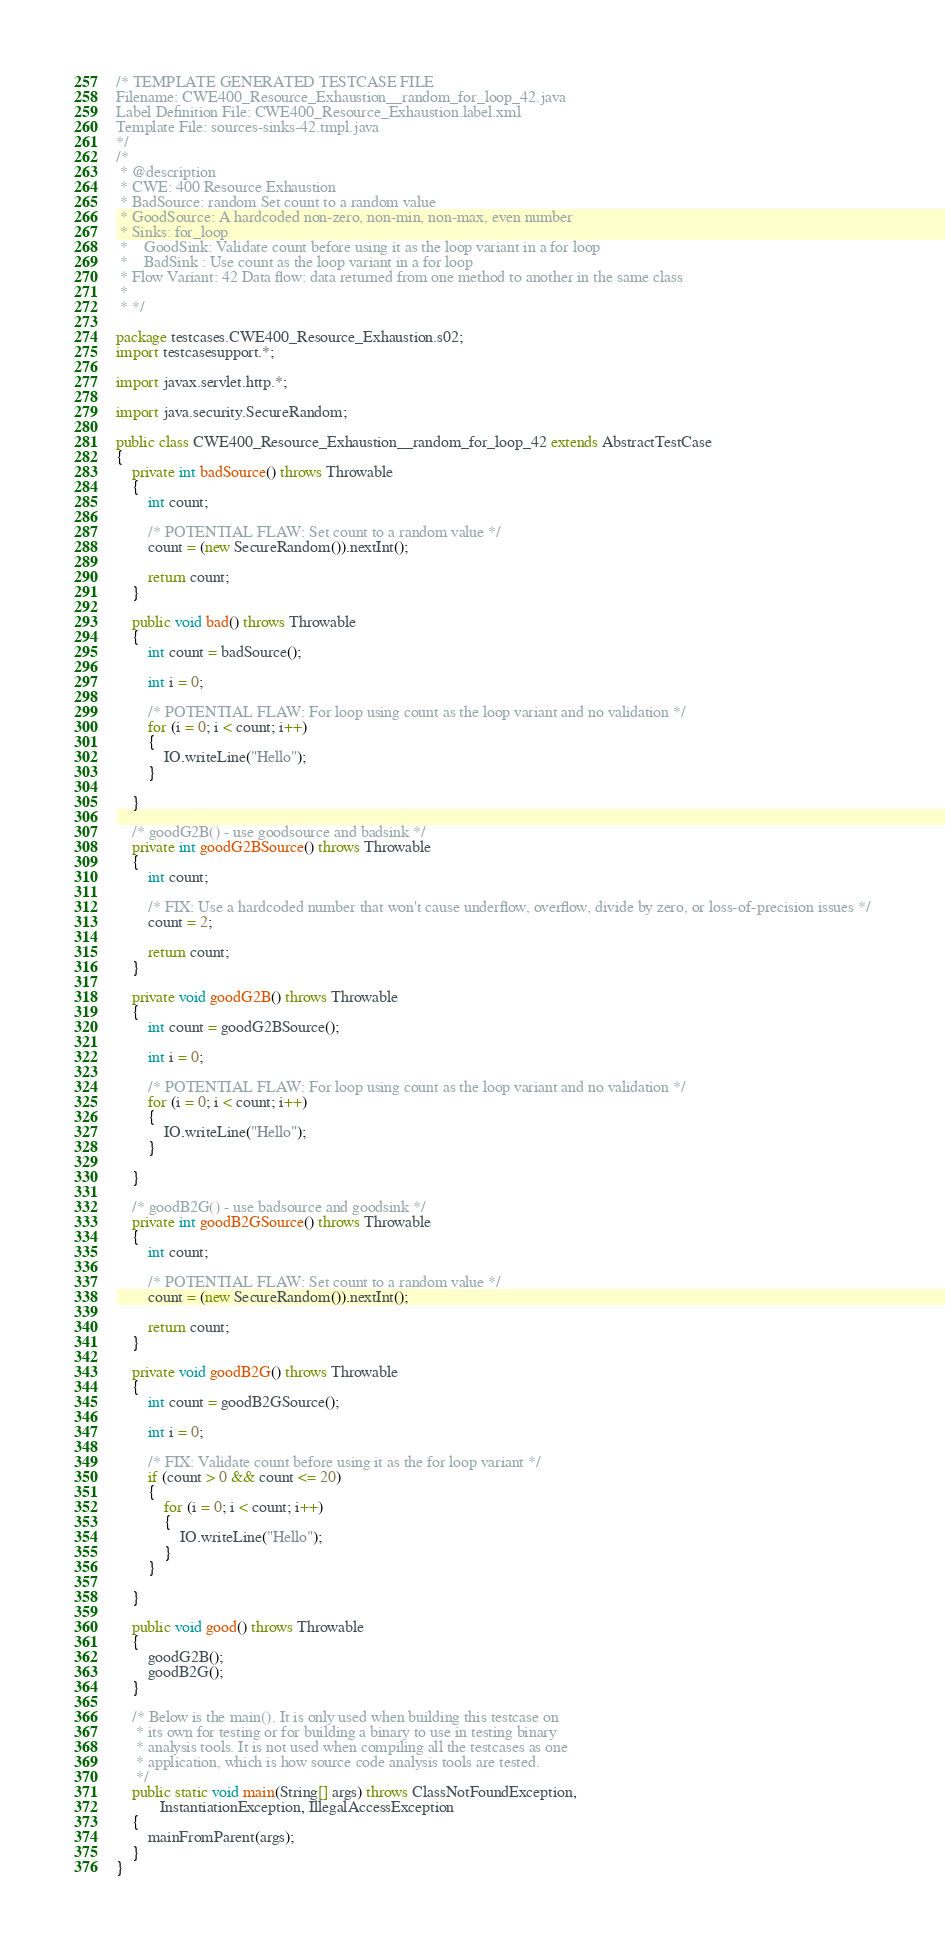<code> <loc_0><loc_0><loc_500><loc_500><_Java_>/* TEMPLATE GENERATED TESTCASE FILE
Filename: CWE400_Resource_Exhaustion__random_for_loop_42.java
Label Definition File: CWE400_Resource_Exhaustion.label.xml
Template File: sources-sinks-42.tmpl.java
*/
/*
 * @description
 * CWE: 400 Resource Exhaustion
 * BadSource: random Set count to a random value
 * GoodSource: A hardcoded non-zero, non-min, non-max, even number
 * Sinks: for_loop
 *    GoodSink: Validate count before using it as the loop variant in a for loop
 *    BadSink : Use count as the loop variant in a for loop
 * Flow Variant: 42 Data flow: data returned from one method to another in the same class
 *
 * */

package testcases.CWE400_Resource_Exhaustion.s02;
import testcasesupport.*;

import javax.servlet.http.*;

import java.security.SecureRandom;

public class CWE400_Resource_Exhaustion__random_for_loop_42 extends AbstractTestCase
{
    private int badSource() throws Throwable
    {
        int count;

        /* POTENTIAL FLAW: Set count to a random value */
        count = (new SecureRandom()).nextInt();

        return count;
    }

    public void bad() throws Throwable
    {
        int count = badSource();

        int i = 0;

        /* POTENTIAL FLAW: For loop using count as the loop variant and no validation */
        for (i = 0; i < count; i++)
        {
            IO.writeLine("Hello");
        }

    }

    /* goodG2B() - use goodsource and badsink */
    private int goodG2BSource() throws Throwable
    {
        int count;

        /* FIX: Use a hardcoded number that won't cause underflow, overflow, divide by zero, or loss-of-precision issues */
        count = 2;

        return count;
    }

    private void goodG2B() throws Throwable
    {
        int count = goodG2BSource();

        int i = 0;

        /* POTENTIAL FLAW: For loop using count as the loop variant and no validation */
        for (i = 0; i < count; i++)
        {
            IO.writeLine("Hello");
        }

    }

    /* goodB2G() - use badsource and goodsink */
    private int goodB2GSource() throws Throwable
    {
        int count;

        /* POTENTIAL FLAW: Set count to a random value */
        count = (new SecureRandom()).nextInt();

        return count;
    }

    private void goodB2G() throws Throwable
    {
        int count = goodB2GSource();

        int i = 0;

        /* FIX: Validate count before using it as the for loop variant */
        if (count > 0 && count <= 20)
        {
            for (i = 0; i < count; i++)
            {
                IO.writeLine("Hello");
            }
        }

    }

    public void good() throws Throwable
    {
        goodG2B();
        goodB2G();
    }

    /* Below is the main(). It is only used when building this testcase on
     * its own for testing or for building a binary to use in testing binary
     * analysis tools. It is not used when compiling all the testcases as one
     * application, which is how source code analysis tools are tested.
     */
    public static void main(String[] args) throws ClassNotFoundException,
           InstantiationException, IllegalAccessException
    {
        mainFromParent(args);
    }
}
</code> 